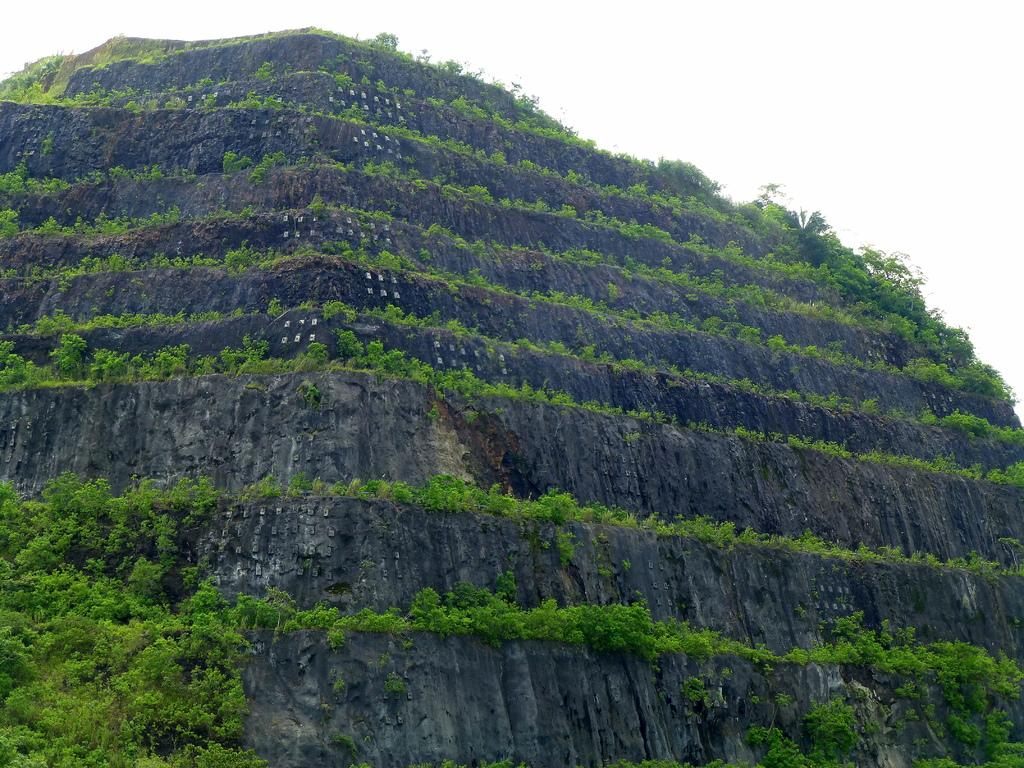What is the main subject of the image? The image depicts a mountain. Are there any vegetation or plants on the mountain? Yes, there are plants on the mountain. What type of ground cover can be seen on the mountain? There is grass on the mountain. How would you describe the sky in the image? The sky is cloudy in the image. Can you see any slaves working on the mountain in the image? There is no reference to any slaves or their work in the image; it depicts a mountain with plants and grass. What type of poisonous substance can be seen on the mountain in the image? There is no poisonous substance present in the image; it features a mountain with plants and grass. 